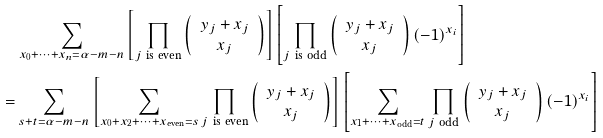<formula> <loc_0><loc_0><loc_500><loc_500>& \sum _ { x _ { 0 } + \cdots + x _ { n } = \alpha - m - n } \left [ \prod _ { j \ \text {is even} } \left ( \begin{array} { c } y _ { j } + x _ { j } \\ x _ { j } \end{array} \right ) \right ] \left [ \prod _ { j \ \text {is odd} } \left ( \begin{array} { c } y _ { j } + x _ { j } \\ x _ { j } \end{array} \right ) ( - 1 ) ^ { x _ { i } } \right ] \\ = & \sum _ { s + t = \alpha - m - n } \left [ \sum _ { x _ { 0 } + x _ { 2 } + \cdots + x _ { \text {even} } = s } \prod _ { j \ \text {is even} } \left ( \begin{array} { c } y _ { j } + x _ { j } \\ x _ { j } \end{array} \right ) \right ] \left [ \sum _ { x _ { 1 } + \cdots + x _ { \text {odd} } = t } \prod _ { j \ \text {odd} } \left ( \begin{array} { c } y _ { j } + x _ { j } \\ x _ { j } \end{array} \right ) ( - 1 ) ^ { x _ { i } } \right ]</formula> 